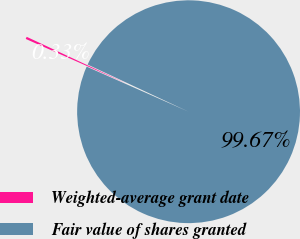<chart> <loc_0><loc_0><loc_500><loc_500><pie_chart><fcel>Weighted-average grant date<fcel>Fair value of shares granted<nl><fcel>0.33%<fcel>99.67%<nl></chart> 